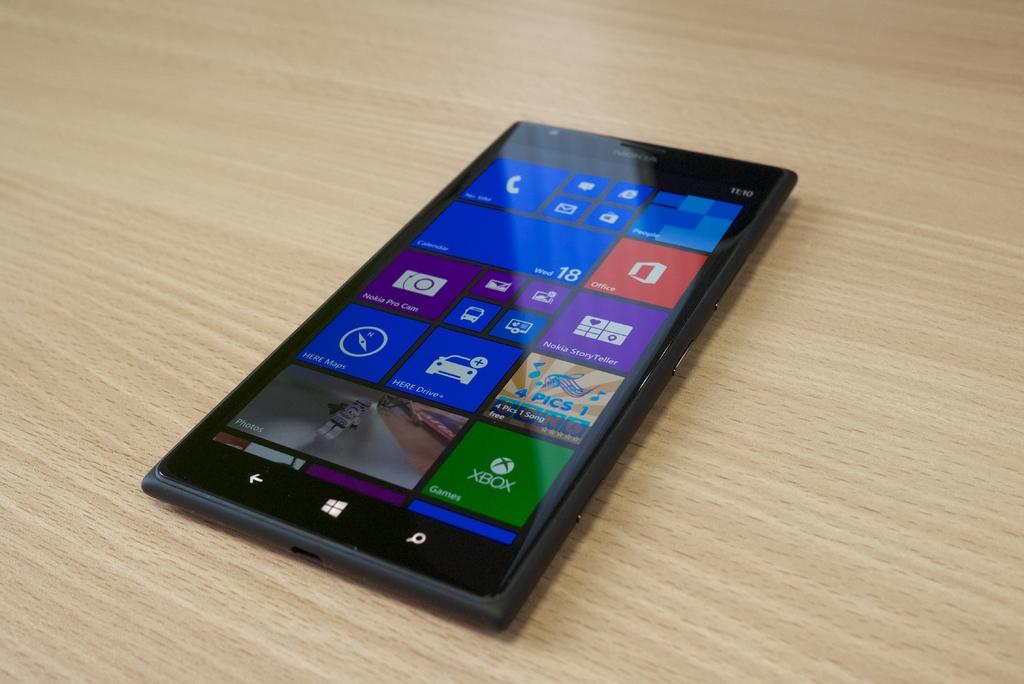<image>
Provide a brief description of the given image. a phone that has a black border around it and an Xbox logo in it 